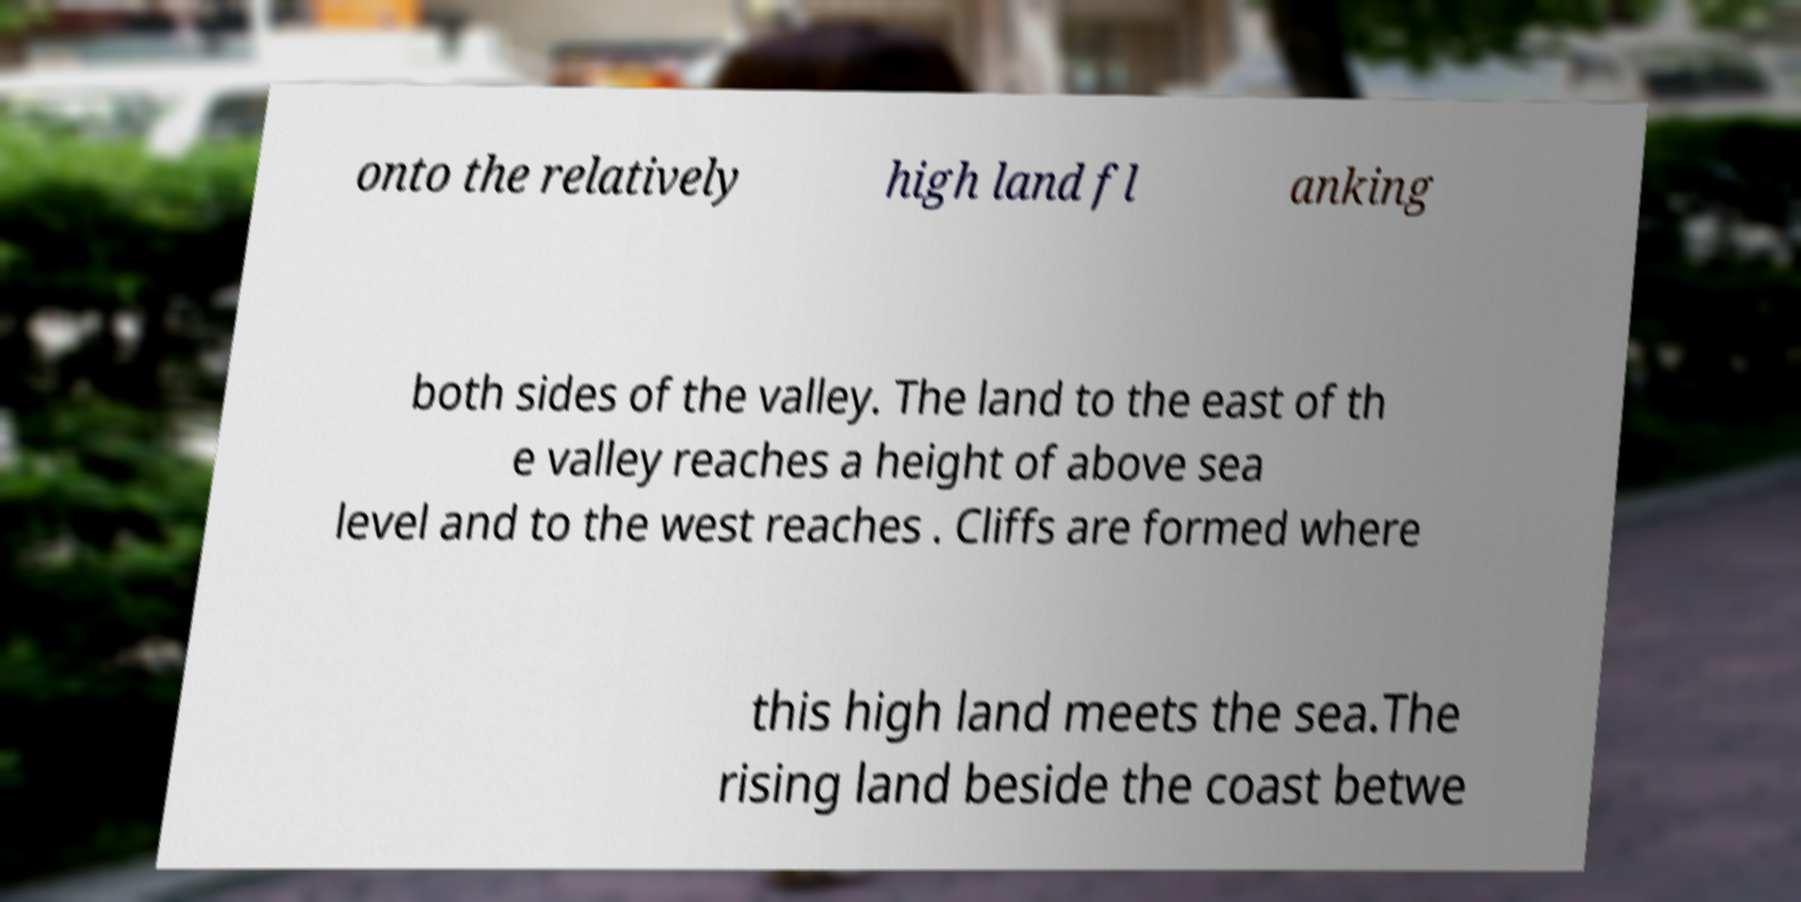Can you accurately transcribe the text from the provided image for me? onto the relatively high land fl anking both sides of the valley. The land to the east of th e valley reaches a height of above sea level and to the west reaches . Cliffs are formed where this high land meets the sea.The rising land beside the coast betwe 